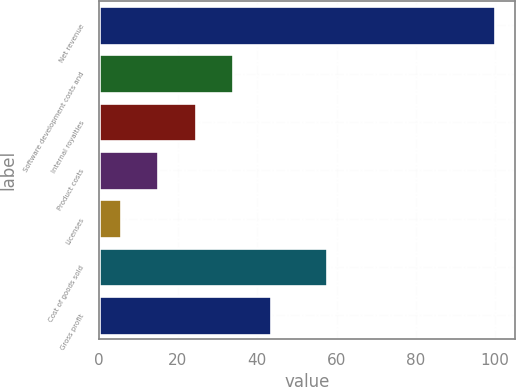<chart> <loc_0><loc_0><loc_500><loc_500><bar_chart><fcel>Net revenue<fcel>Software development costs and<fcel>Internal royalties<fcel>Product costs<fcel>Licenses<fcel>Cost of goods sold<fcel>Gross profit<nl><fcel>100<fcel>33.92<fcel>24.48<fcel>15.04<fcel>5.6<fcel>57.5<fcel>43.36<nl></chart> 